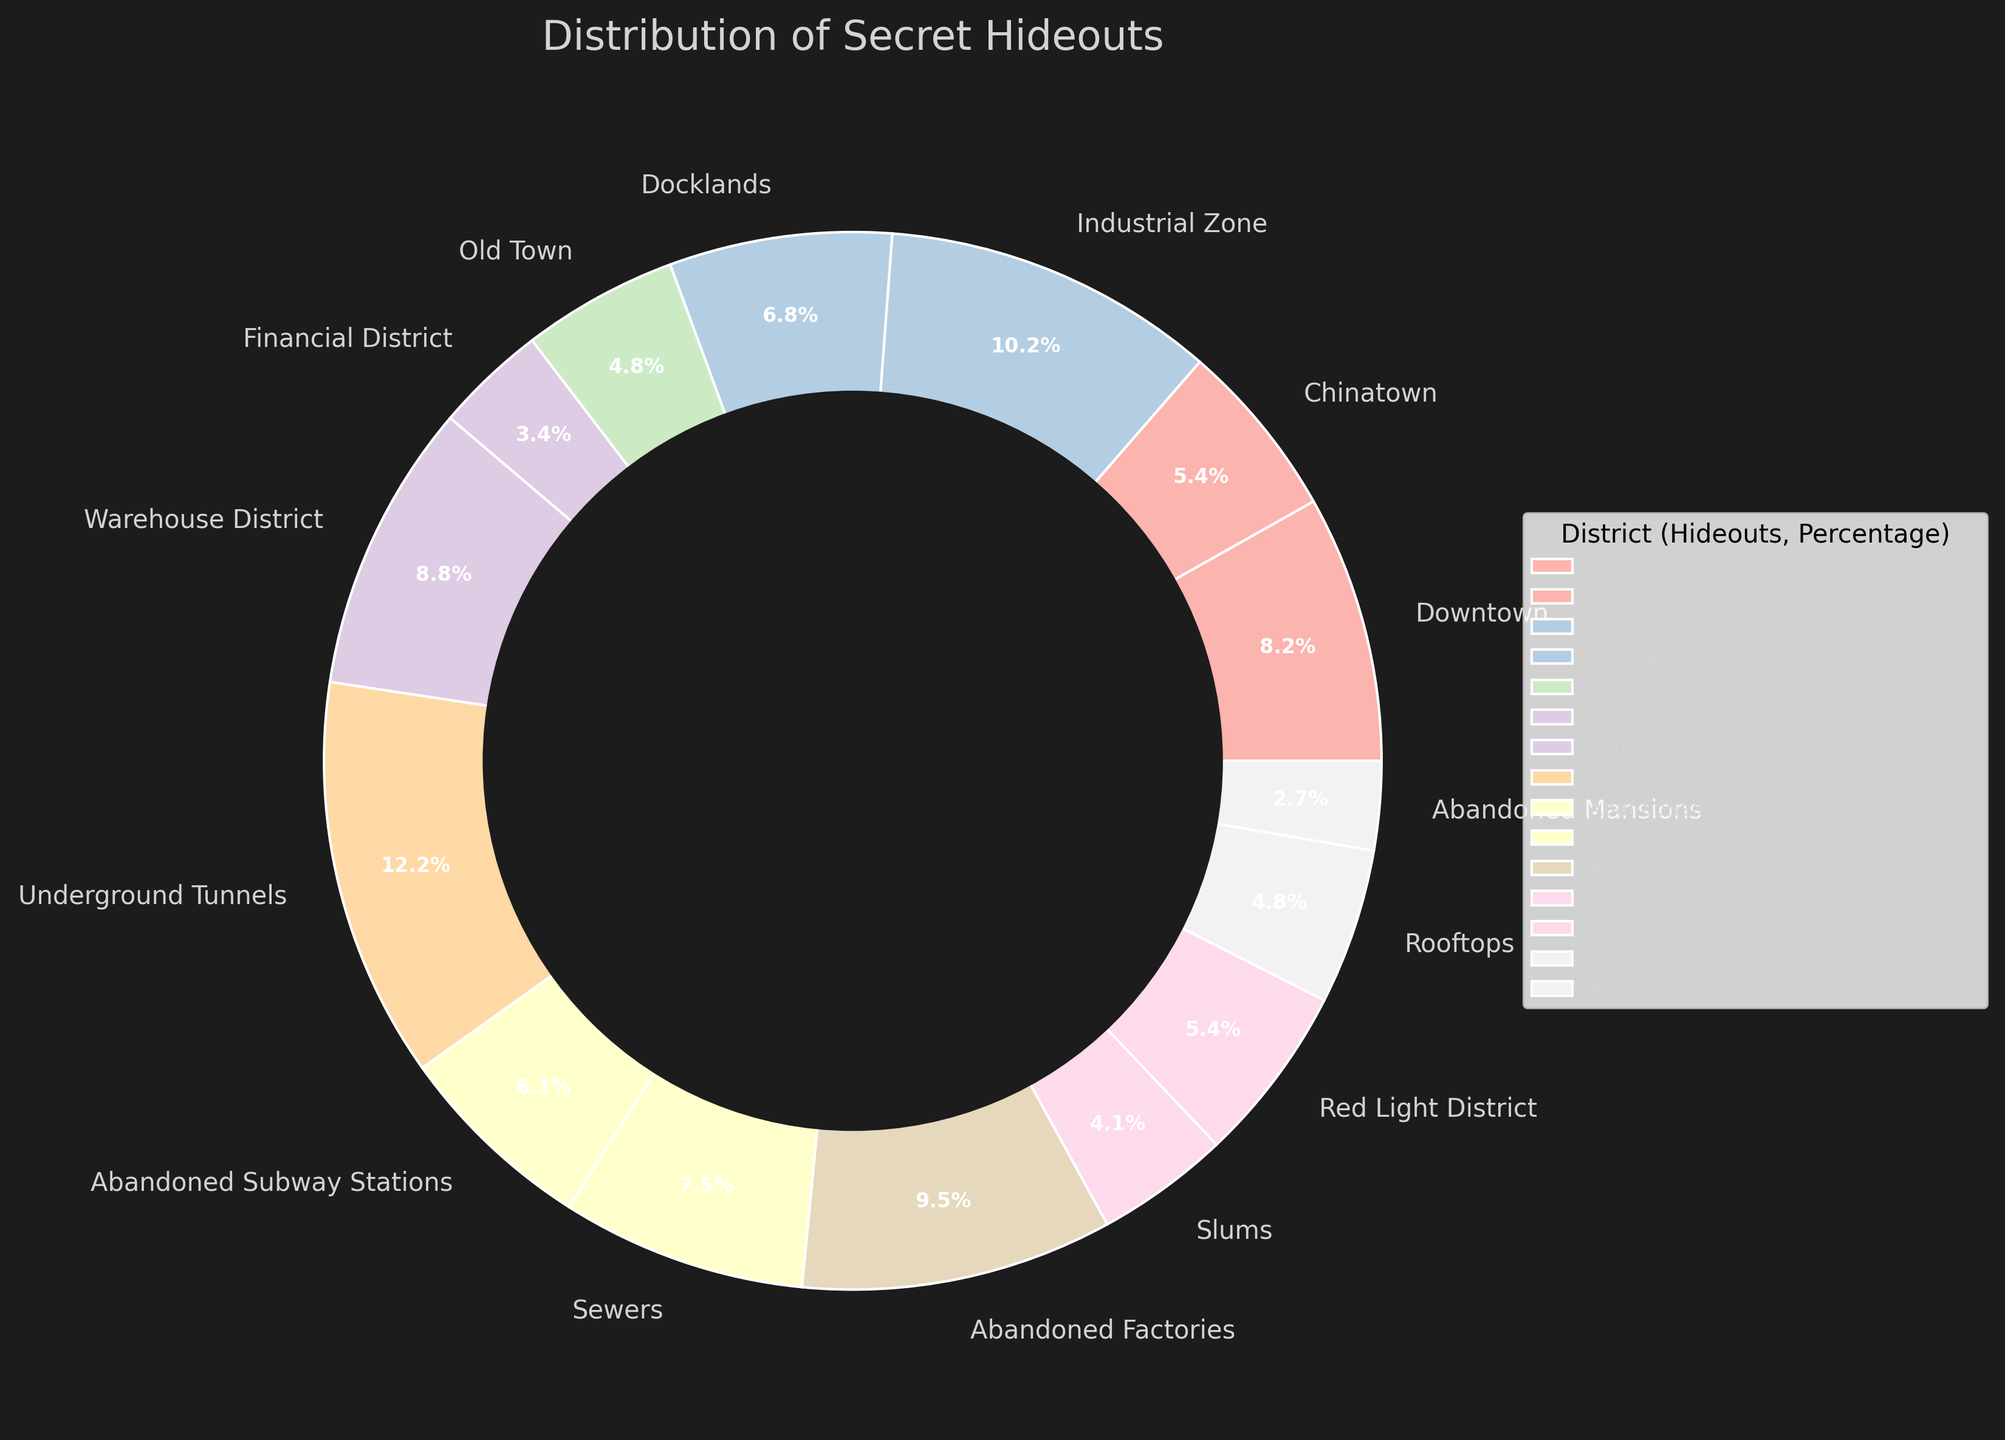Which district has the highest number of secret hideouts? The pie chart shows that the Underground Tunnels have the largest wedge, indicating the highest number with 18 hideouts.
Answer: Underground Tunnels Which district has fewer hideouts, Sewers or Slums? The pie chart shows that Sewers have 11 hideouts and the Slums have 6 hideouts. So, Slums have fewer hideouts.
Answer: Slums How many hideouts are there in Downtown and Docklands combined? According to the pie chart, Downtown has 12 hideouts, and Docklands has 10 hideouts. Their combined total is 12 + 10 = 22.
Answer: 22 What is the total number of hideouts in districts with fewer than 10 hideouts? According to the pie chart, the districts with fewer than 10 hideouts are Financial District (5), Old Town (7), Slums (6), Red Light District (8), and Abandoned Mansions (4). Summing them gives 5 + 7 + 6 + 8 + 4 = 30.
Answer: 30 Among the districts shown, which two have the same number of hideouts? The pie chart shows that both Chinatown and Red Light District have 8 hideouts each.
Answer: Chinatown and Red Light District How many districts have more than 10 hideouts? The pie chart shows that Downtown (12), Industrial Zone (15), Warehouse District (13), Underground Tunnels (18), Sewers (11), and Abandoned Factories (14) each have more than 10 hideouts. Thus, there are 6 districts in total.
Answer: 6 Which is larger, the total number of hideouts in the Rooftops and Abandoned Subway Stations combined, or in the Abandoned Factories alone? The pie chart indicates that Rooftops have 7, and Abandoned Subway Stations have 9, making their total 7 + 9 = 16. The Abandoned Factories have 14 hideouts. Therefore, the combined total of Rooftops and Abandoned Subway Stations is larger.
Answer: Combined total of Rooftops and Abandoned Subway Stations Calculate the average number of hideouts per district. There are 15 districts in total. Summing the number of hideouts: (12 + 8 + 15 + 10 + 7 + 5 + 13 + 18 + 9 + 11 + 14 + 6 + 8 + 7 + 4) = 147. Dividing by the number of districts: 147 / 15 = 9.8.
Answer: 9.8 Which color represents the district with the fewest number of hideouts, and how many hideouts are there? The pie chart's legend indicates that the Abandoned Mansions have the fewest hideouts (4). They are represented in a pale color from the chosen palette.
Answer: Pale color, 4 What is the difference between the total number of hideouts in the Industrial Zone and Financial District? The pie chart shows the Industrial Zone has 15 hideouts, and Financial District has 5 hideouts. The difference is 15 - 5 = 10.
Answer: 10 